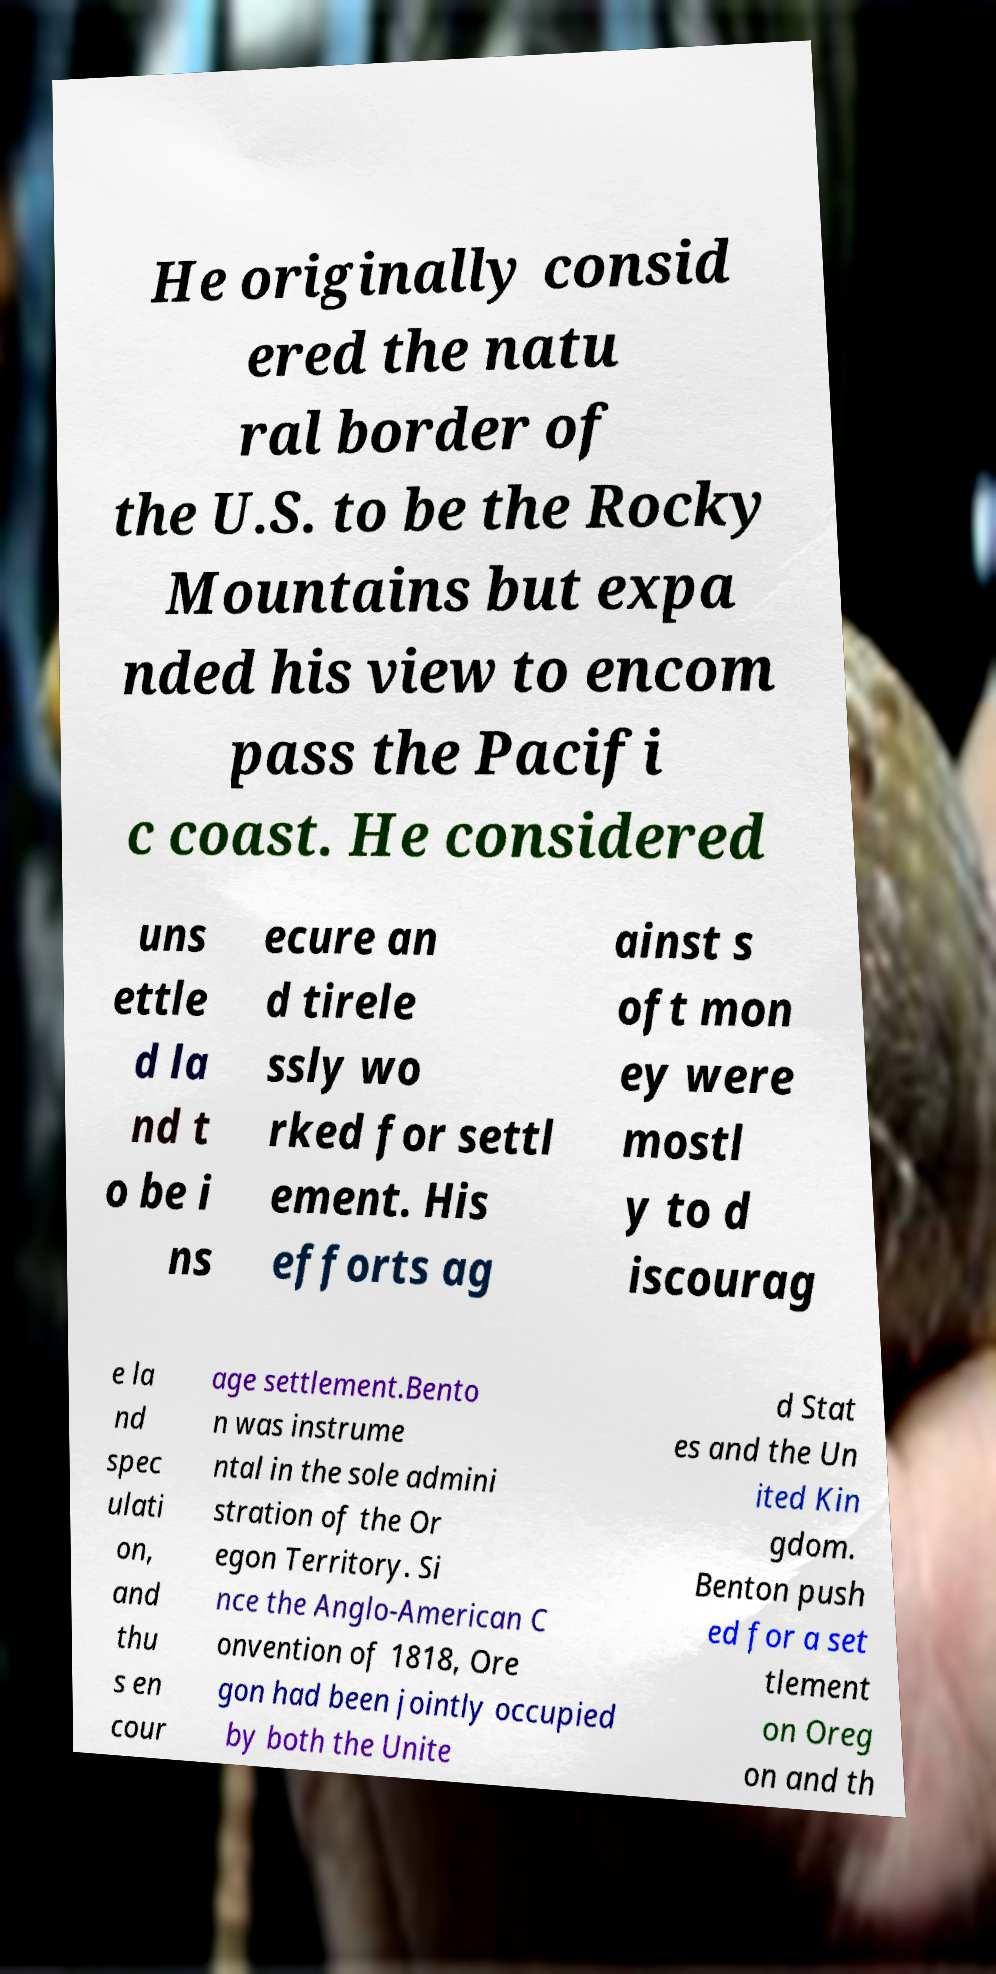There's text embedded in this image that I need extracted. Can you transcribe it verbatim? He originally consid ered the natu ral border of the U.S. to be the Rocky Mountains but expa nded his view to encom pass the Pacifi c coast. He considered uns ettle d la nd t o be i ns ecure an d tirele ssly wo rked for settl ement. His efforts ag ainst s oft mon ey were mostl y to d iscourag e la nd spec ulati on, and thu s en cour age settlement.Bento n was instrume ntal in the sole admini stration of the Or egon Territory. Si nce the Anglo-American C onvention of 1818, Ore gon had been jointly occupied by both the Unite d Stat es and the Un ited Kin gdom. Benton push ed for a set tlement on Oreg on and th 